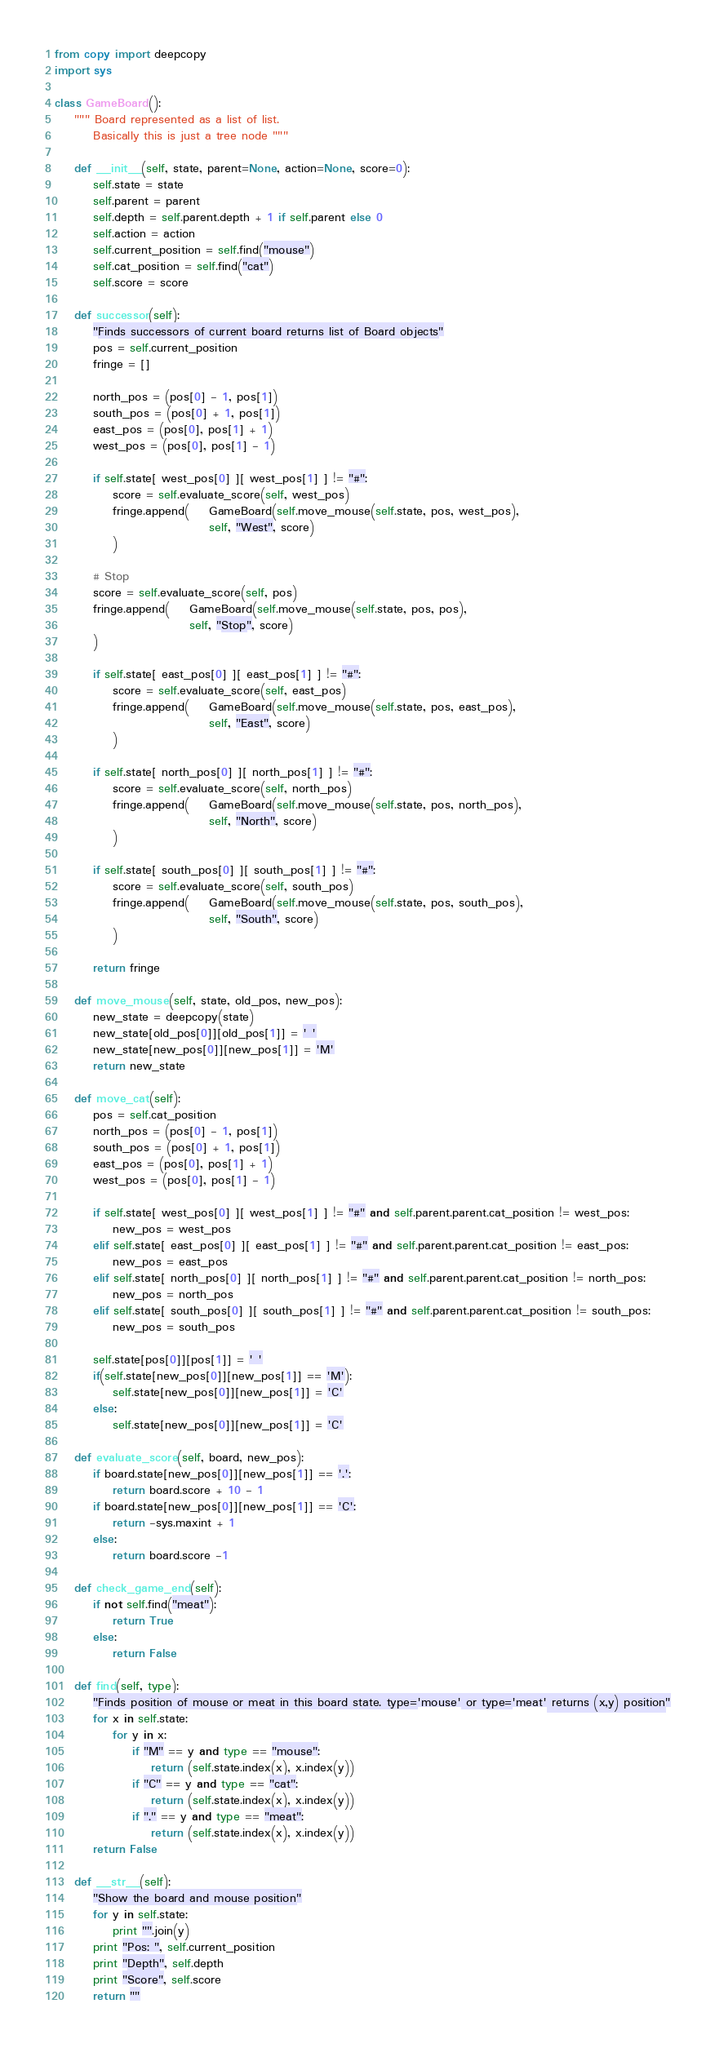<code> <loc_0><loc_0><loc_500><loc_500><_Python_>from copy import deepcopy
import sys

class GameBoard():
	""" Board represented as a list of list. 
		Basically this is just a tree node """

	def __init__(self, state, parent=None, action=None, score=0):
		self.state = state
		self.parent = parent
		self.depth = self.parent.depth + 1 if self.parent else 0
		self.action = action
		self.current_position = self.find("mouse")
		self.cat_position = self.find("cat")
		self.score = score

	def successor(self):
		"Finds successors of current board returns list of Board objects"
		pos = self.current_position
		fringe = []

		north_pos = (pos[0] - 1, pos[1])
		south_pos = (pos[0] + 1, pos[1])
		east_pos = (pos[0], pos[1] + 1)
		west_pos = (pos[0], pos[1] - 1)

		if self.state[ west_pos[0] ][ west_pos[1] ] != "#":
			score = self.evaluate_score(self, west_pos)
			fringe.append(	GameBoard(self.move_mouse(self.state, pos, west_pos), 
								self, "West", score)
			)

		# Stop
		score = self.evaluate_score(self, pos)
		fringe.append(	GameBoard(self.move_mouse(self.state, pos, pos), 
							self, "Stop", score)
		)

		if self.state[ east_pos[0] ][ east_pos[1] ] != "#":
			score = self.evaluate_score(self, east_pos)
			fringe.append(	GameBoard(self.move_mouse(self.state, pos, east_pos), 
								self, "East", score)
			)

		if self.state[ north_pos[0] ][ north_pos[1] ] != "#":
			score = self.evaluate_score(self, north_pos)
			fringe.append(	GameBoard(self.move_mouse(self.state, pos, north_pos), 
								self, "North", score)
			)

		if self.state[ south_pos[0] ][ south_pos[1] ] != "#":
			score = self.evaluate_score(self, south_pos)
			fringe.append(	GameBoard(self.move_mouse(self.state, pos, south_pos), 
								self, "South", score)
			)

		return fringe

	def move_mouse(self, state, old_pos, new_pos):
		new_state = deepcopy(state)
		new_state[old_pos[0]][old_pos[1]] = ' '
		new_state[new_pos[0]][new_pos[1]] = 'M'
		return new_state

	def move_cat(self):
		pos = self.cat_position
		north_pos = (pos[0] - 1, pos[1])
		south_pos = (pos[0] + 1, pos[1])
		east_pos = (pos[0], pos[1] + 1)
		west_pos = (pos[0], pos[1] - 1)

		if self.state[ west_pos[0] ][ west_pos[1] ] != "#" and self.parent.parent.cat_position != west_pos:
			new_pos = west_pos
		elif self.state[ east_pos[0] ][ east_pos[1] ] != "#" and self.parent.parent.cat_position != east_pos:
			new_pos = east_pos
		elif self.state[ north_pos[0] ][ north_pos[1] ] != "#" and self.parent.parent.cat_position != north_pos:
			new_pos = north_pos
		elif self.state[ south_pos[0] ][ south_pos[1] ] != "#" and self.parent.parent.cat_position != south_pos:
			new_pos = south_pos

		self.state[pos[0]][pos[1]] = ' '
		if(self.state[new_pos[0]][new_pos[1]] == 'M'):
			self.state[new_pos[0]][new_pos[1]] = 'C'
		else:
			self.state[new_pos[0]][new_pos[1]] = 'C'

	def evaluate_score(self, board, new_pos):
		if board.state[new_pos[0]][new_pos[1]] == '.':
			return board.score + 10 - 1
		if board.state[new_pos[0]][new_pos[1]] == 'C':
			return -sys.maxint + 1
		else:
			return board.score -1

	def check_game_end(self):
		if not self.find("meat"):
			return True
		else:
			return False

	def find(self, type):
		"Finds position of mouse or meat in this board state. type='mouse' or type='meat' returns (x,y) position"
		for x in self.state:
			for y in x:
				if "M" == y and type == "mouse":
					return (self.state.index(x), x.index(y))
				if "C" == y and type == "cat":
					return (self.state.index(x), x.index(y))
				if "." == y and type == "meat":
					return (self.state.index(x), x.index(y))
		return False

	def __str__(self):
		"Show the board and mouse position"
		for y in self.state:
			print "".join(y)
		print "Pos: ", self.current_position
		print "Depth", self.depth
		print "Score", self.score
		return ""</code> 